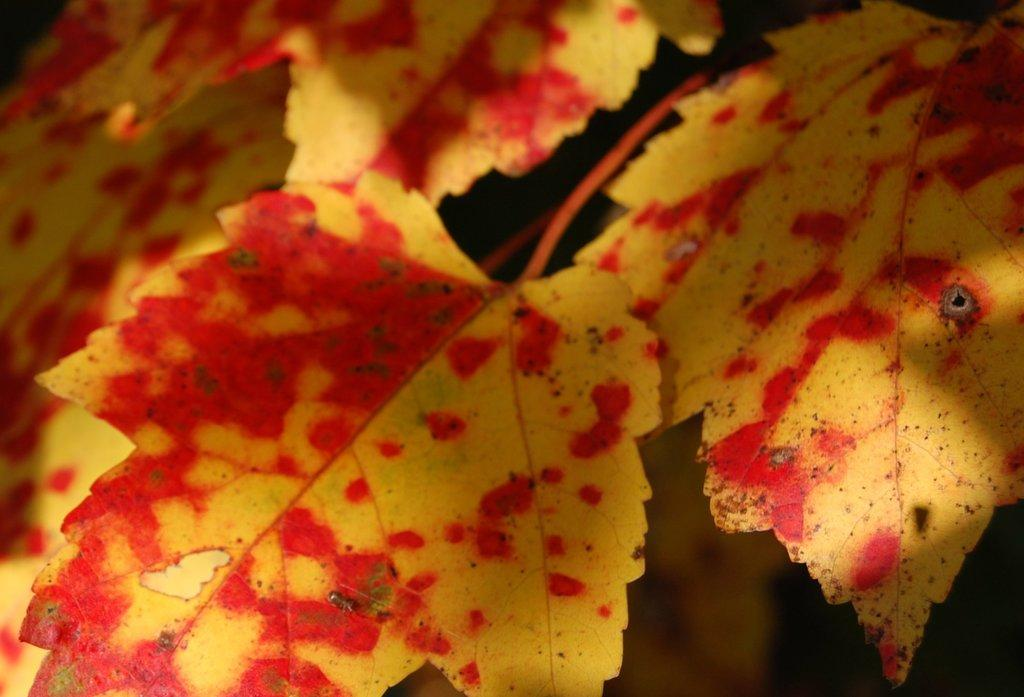What type of natural elements can be seen in the image? There are leaves in the image. What colors are the leaves in the image? The leaves are in brown and red colors. What is the color of the background in the image? The background of the image is black. What type of organization is depicted in the image? There is no organization depicted in the image; it features leaves in brown and red colors with a black background. What type of building can be seen in the image? There is no building present in the image; it features leaves in brown and red colors with a black background. 